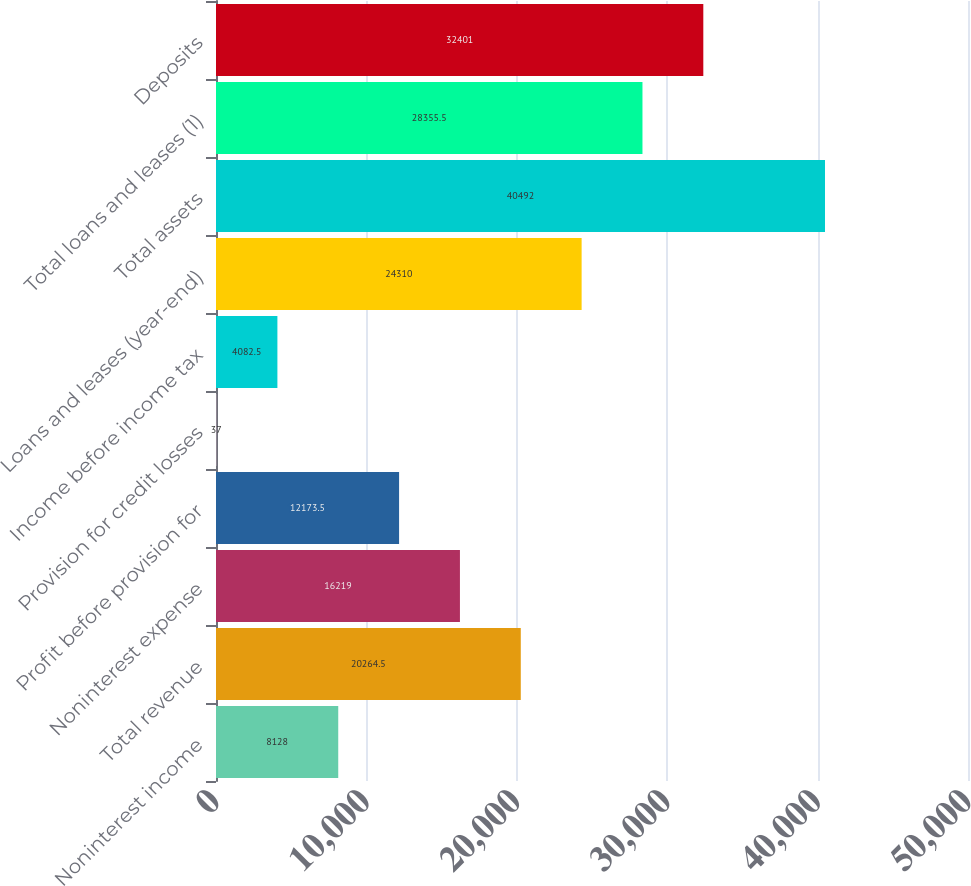<chart> <loc_0><loc_0><loc_500><loc_500><bar_chart><fcel>Noninterest income<fcel>Total revenue<fcel>Noninterest expense<fcel>Profit before provision for<fcel>Provision for credit losses<fcel>Income before income tax<fcel>Loans and leases (year-end)<fcel>Total assets<fcel>Total loans and leases (1)<fcel>Deposits<nl><fcel>8128<fcel>20264.5<fcel>16219<fcel>12173.5<fcel>37<fcel>4082.5<fcel>24310<fcel>40492<fcel>28355.5<fcel>32401<nl></chart> 